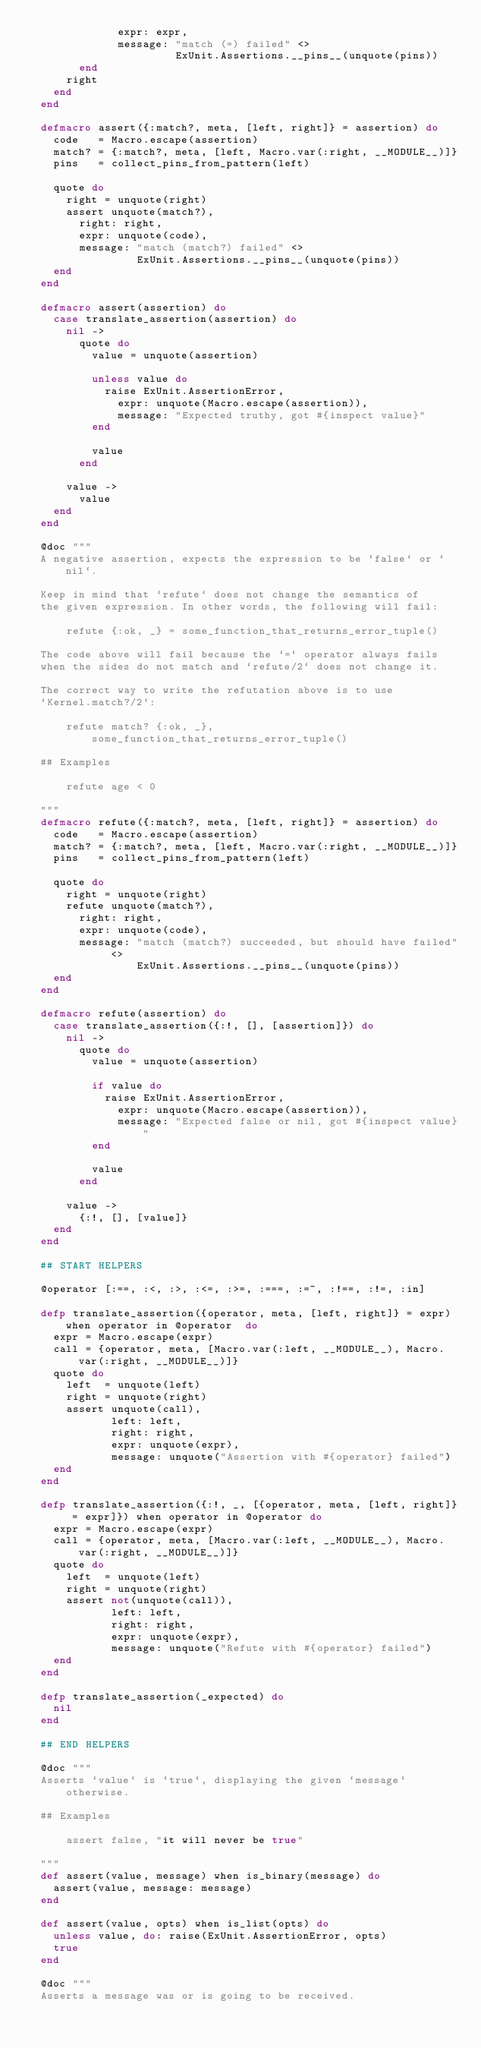Convert code to text. <code><loc_0><loc_0><loc_500><loc_500><_Elixir_>              expr: expr,
              message: "match (=) failed" <>
                       ExUnit.Assertions.__pins__(unquote(pins))
        end
      right
    end
  end

  defmacro assert({:match?, meta, [left, right]} = assertion) do
    code   = Macro.escape(assertion)
    match? = {:match?, meta, [left, Macro.var(:right, __MODULE__)]}
    pins   = collect_pins_from_pattern(left)

    quote do
      right = unquote(right)
      assert unquote(match?),
        right: right,
        expr: unquote(code),
        message: "match (match?) failed" <>
                 ExUnit.Assertions.__pins__(unquote(pins))
    end
  end

  defmacro assert(assertion) do
    case translate_assertion(assertion) do
      nil ->
        quote do
          value = unquote(assertion)

          unless value do
            raise ExUnit.AssertionError,
              expr: unquote(Macro.escape(assertion)),
              message: "Expected truthy, got #{inspect value}"
          end

          value
        end

      value ->
        value
    end
  end

  @doc """
  A negative assertion, expects the expression to be `false` or `nil`.

  Keep in mind that `refute` does not change the semantics of
  the given expression. In other words, the following will fail:

      refute {:ok, _} = some_function_that_returns_error_tuple()

  The code above will fail because the `=` operator always fails
  when the sides do not match and `refute/2` does not change it.

  The correct way to write the refutation above is to use
  `Kernel.match?/2`:

      refute match? {:ok, _}, some_function_that_returns_error_tuple()

  ## Examples

      refute age < 0

  """
  defmacro refute({:match?, meta, [left, right]} = assertion) do
    code   = Macro.escape(assertion)
    match? = {:match?, meta, [left, Macro.var(:right, __MODULE__)]}
    pins   = collect_pins_from_pattern(left)

    quote do
      right = unquote(right)
      refute unquote(match?),
        right: right,
        expr: unquote(code),
        message: "match (match?) succeeded, but should have failed" <>
                 ExUnit.Assertions.__pins__(unquote(pins))
    end
  end

  defmacro refute(assertion) do
    case translate_assertion({:!, [], [assertion]}) do
      nil ->
        quote do
          value = unquote(assertion)

          if value do
            raise ExUnit.AssertionError,
              expr: unquote(Macro.escape(assertion)),
              message: "Expected false or nil, got #{inspect value}"
          end

          value
        end

      value ->
        {:!, [], [value]}
    end
  end

  ## START HELPERS

  @operator [:==, :<, :>, :<=, :>=, :===, :=~, :!==, :!=, :in]

  defp translate_assertion({operator, meta, [left, right]} = expr) when operator in @operator  do
    expr = Macro.escape(expr)
    call = {operator, meta, [Macro.var(:left, __MODULE__), Macro.var(:right, __MODULE__)]}
    quote do
      left  = unquote(left)
      right = unquote(right)
      assert unquote(call),
             left: left,
             right: right,
             expr: unquote(expr),
             message: unquote("Assertion with #{operator} failed")
    end
  end

  defp translate_assertion({:!, _, [{operator, meta, [left, right]} = expr]}) when operator in @operator do
    expr = Macro.escape(expr)
    call = {operator, meta, [Macro.var(:left, __MODULE__), Macro.var(:right, __MODULE__)]}
    quote do
      left  = unquote(left)
      right = unquote(right)
      assert not(unquote(call)),
             left: left,
             right: right,
             expr: unquote(expr),
             message: unquote("Refute with #{operator} failed")
    end
  end

  defp translate_assertion(_expected) do
    nil
  end

  ## END HELPERS

  @doc """
  Asserts `value` is `true`, displaying the given `message` otherwise.

  ## Examples

      assert false, "it will never be true"

  """
  def assert(value, message) when is_binary(message) do
    assert(value, message: message)
  end

  def assert(value, opts) when is_list(opts) do
    unless value, do: raise(ExUnit.AssertionError, opts)
    true
  end

  @doc """
  Asserts a message was or is going to be received.
</code> 